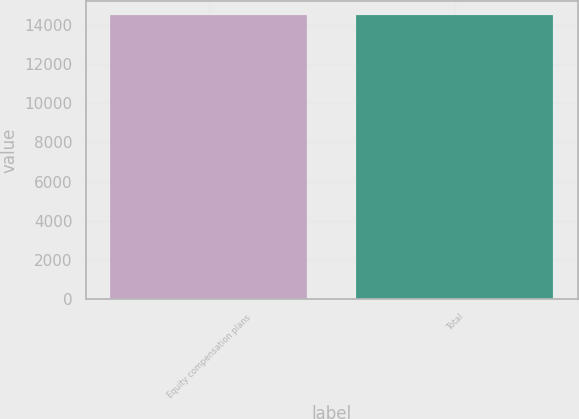Convert chart to OTSL. <chart><loc_0><loc_0><loc_500><loc_500><bar_chart><fcel>Equity compensation plans<fcel>Total<nl><fcel>14473<fcel>14473.1<nl></chart> 